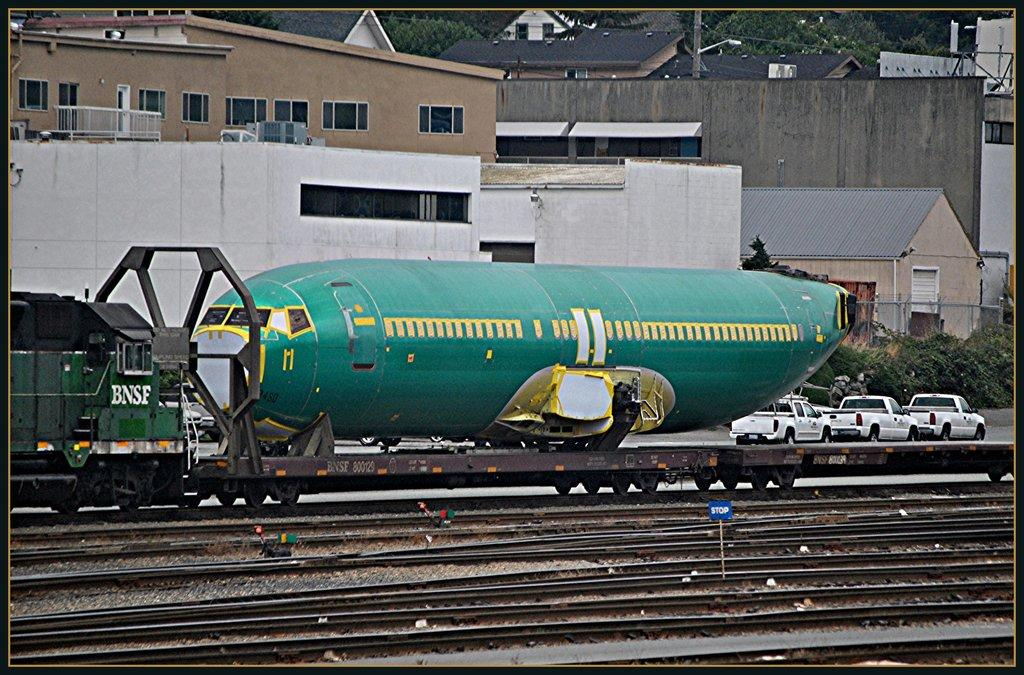<image>
Describe the image concisely. Train with the letters BNSF on it is transporting something. 